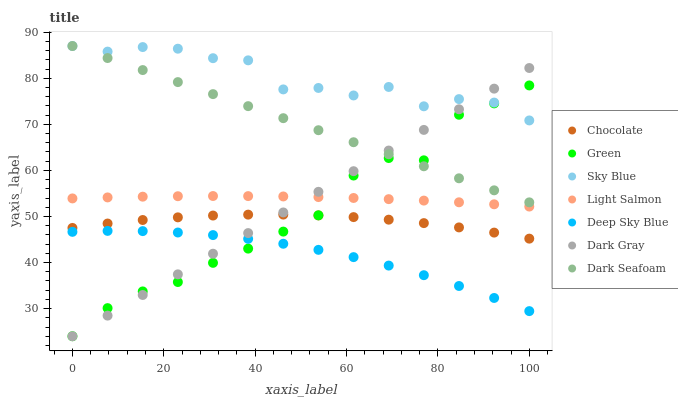Does Deep Sky Blue have the minimum area under the curve?
Answer yes or no. Yes. Does Sky Blue have the maximum area under the curve?
Answer yes or no. Yes. Does Chocolate have the minimum area under the curve?
Answer yes or no. No. Does Chocolate have the maximum area under the curve?
Answer yes or no. No. Is Dark Gray the smoothest?
Answer yes or no. Yes. Is Sky Blue the roughest?
Answer yes or no. Yes. Is Chocolate the smoothest?
Answer yes or no. No. Is Chocolate the roughest?
Answer yes or no. No. Does Dark Gray have the lowest value?
Answer yes or no. Yes. Does Chocolate have the lowest value?
Answer yes or no. No. Does Sky Blue have the highest value?
Answer yes or no. Yes. Does Chocolate have the highest value?
Answer yes or no. No. Is Chocolate less than Dark Seafoam?
Answer yes or no. Yes. Is Sky Blue greater than Deep Sky Blue?
Answer yes or no. Yes. Does Dark Gray intersect Green?
Answer yes or no. Yes. Is Dark Gray less than Green?
Answer yes or no. No. Is Dark Gray greater than Green?
Answer yes or no. No. Does Chocolate intersect Dark Seafoam?
Answer yes or no. No. 